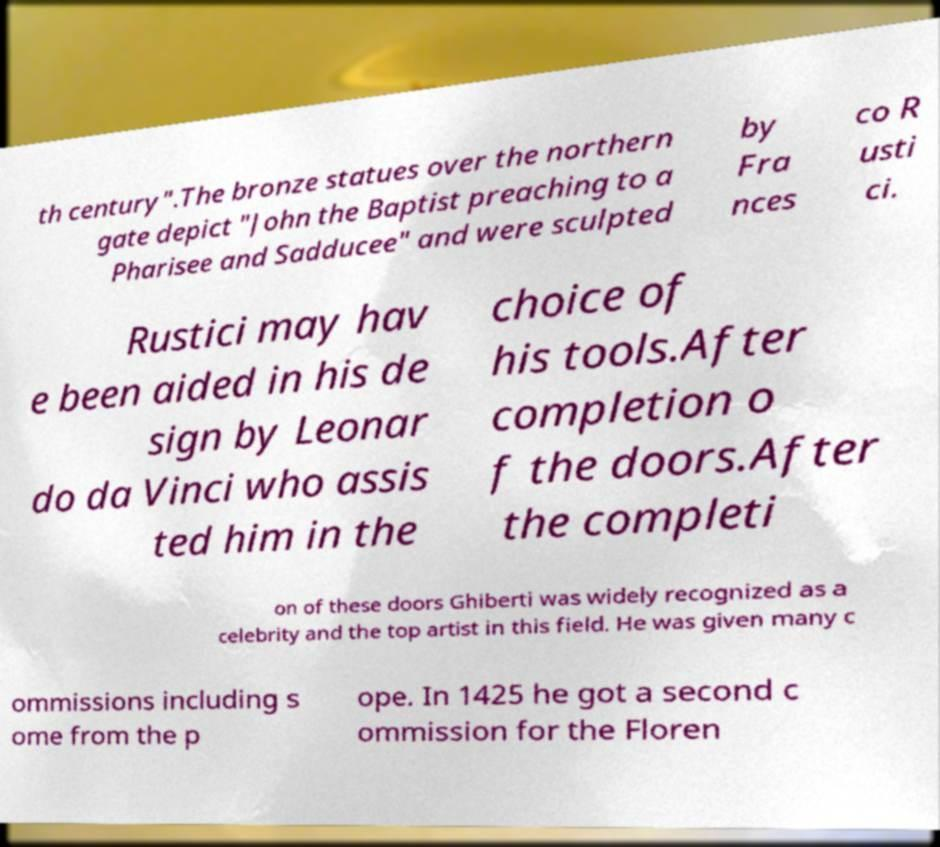I need the written content from this picture converted into text. Can you do that? th century".The bronze statues over the northern gate depict "John the Baptist preaching to a Pharisee and Sadducee" and were sculpted by Fra nces co R usti ci. Rustici may hav e been aided in his de sign by Leonar do da Vinci who assis ted him in the choice of his tools.After completion o f the doors.After the completi on of these doors Ghiberti was widely recognized as a celebrity and the top artist in this field. He was given many c ommissions including s ome from the p ope. In 1425 he got a second c ommission for the Floren 